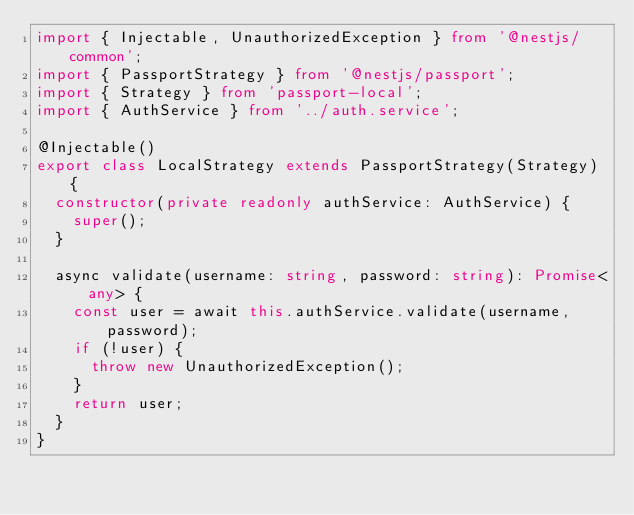<code> <loc_0><loc_0><loc_500><loc_500><_TypeScript_>import { Injectable, UnauthorizedException } from '@nestjs/common';
import { PassportStrategy } from '@nestjs/passport';
import { Strategy } from 'passport-local';
import { AuthService } from '../auth.service';

@Injectable()
export class LocalStrategy extends PassportStrategy(Strategy) {
  constructor(private readonly authService: AuthService) {
    super();
  }

  async validate(username: string, password: string): Promise<any> {
    const user = await this.authService.validate(username, password);
    if (!user) {
      throw new UnauthorizedException();
    }
    return user;
  }
}</code> 